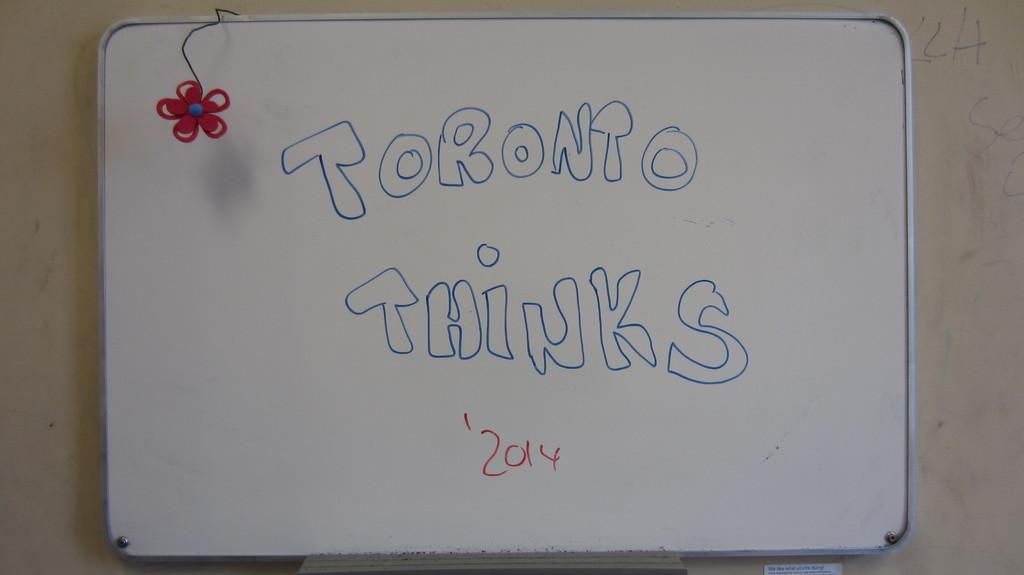What country thinks?
Offer a terse response. Toronto. What year is written on this whiteboard?
Give a very brief answer. 2014. 